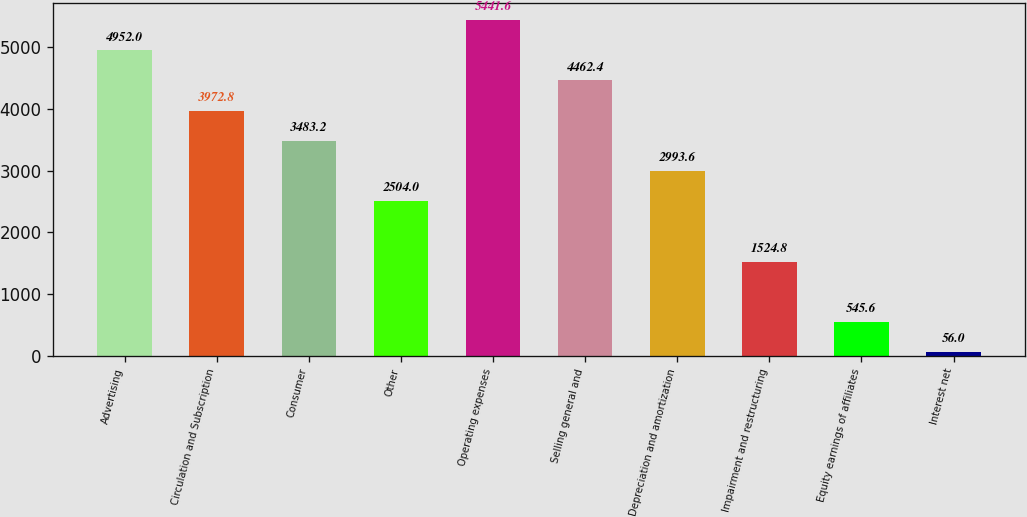Convert chart. <chart><loc_0><loc_0><loc_500><loc_500><bar_chart><fcel>Advertising<fcel>Circulation and Subscription<fcel>Consumer<fcel>Other<fcel>Operating expenses<fcel>Selling general and<fcel>Depreciation and amortization<fcel>Impairment and restructuring<fcel>Equity earnings of affiliates<fcel>Interest net<nl><fcel>4952<fcel>3972.8<fcel>3483.2<fcel>2504<fcel>5441.6<fcel>4462.4<fcel>2993.6<fcel>1524.8<fcel>545.6<fcel>56<nl></chart> 